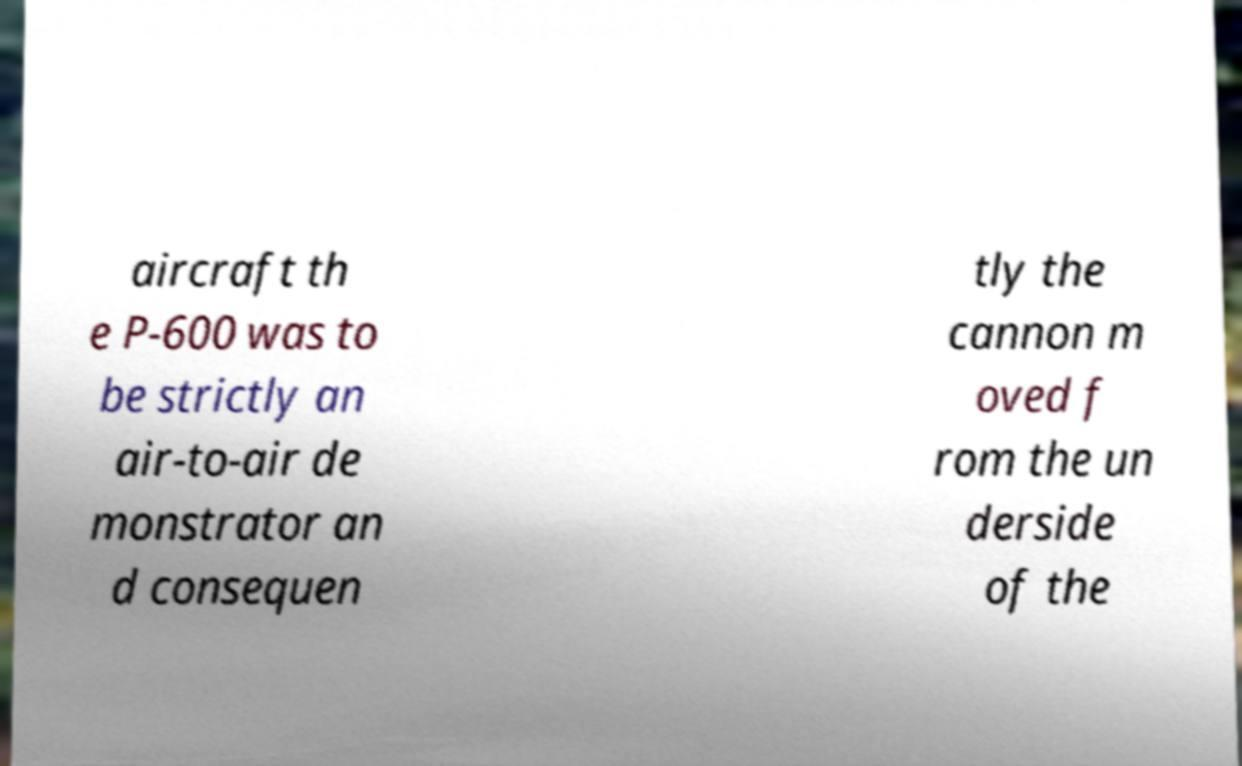Could you extract and type out the text from this image? aircraft th e P-600 was to be strictly an air-to-air de monstrator an d consequen tly the cannon m oved f rom the un derside of the 